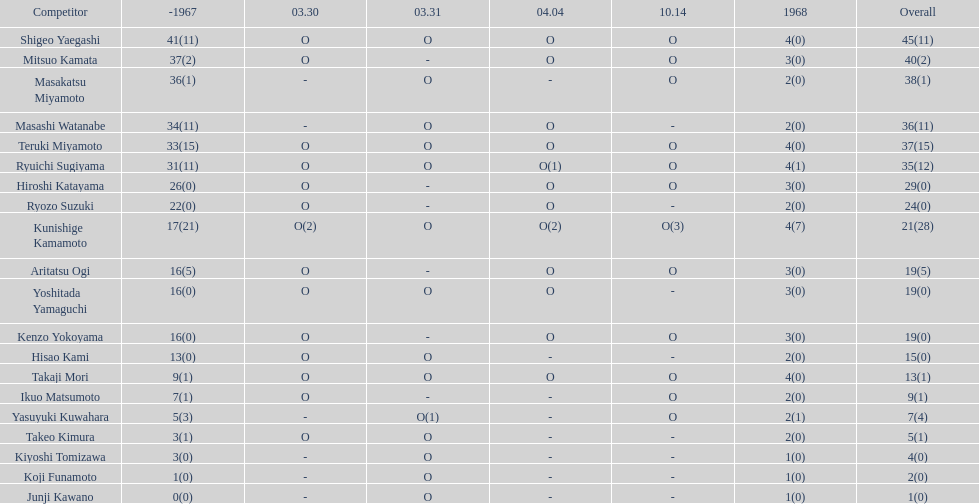By how many appearances does shigeo yaegashi's total surpass mitsuo kamata's total? 5. 